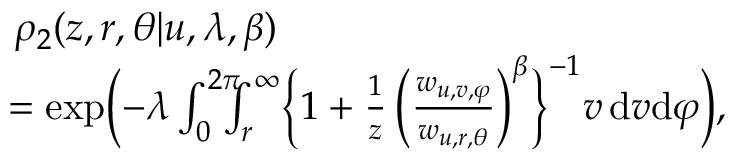Convert formula to latex. <formula><loc_0><loc_0><loc_500><loc_500>\begin{array} { r l } & { \, \rho _ { 2 } ( z , r , \theta | u , \lambda , \beta ) } \\ & { \, = \exp \left ( - \lambda \int _ { 0 } ^ { 2 \pi } \, \int _ { r } ^ { \infty } \left \{ 1 + \frac { 1 } { z } \, \left ( \frac { w _ { u , v , \varphi } } { w _ { u , r , \theta } } \right ) ^ { \beta } \right \} ^ { - 1 } v \, d v d \varphi \right ) , } \end{array}</formula> 